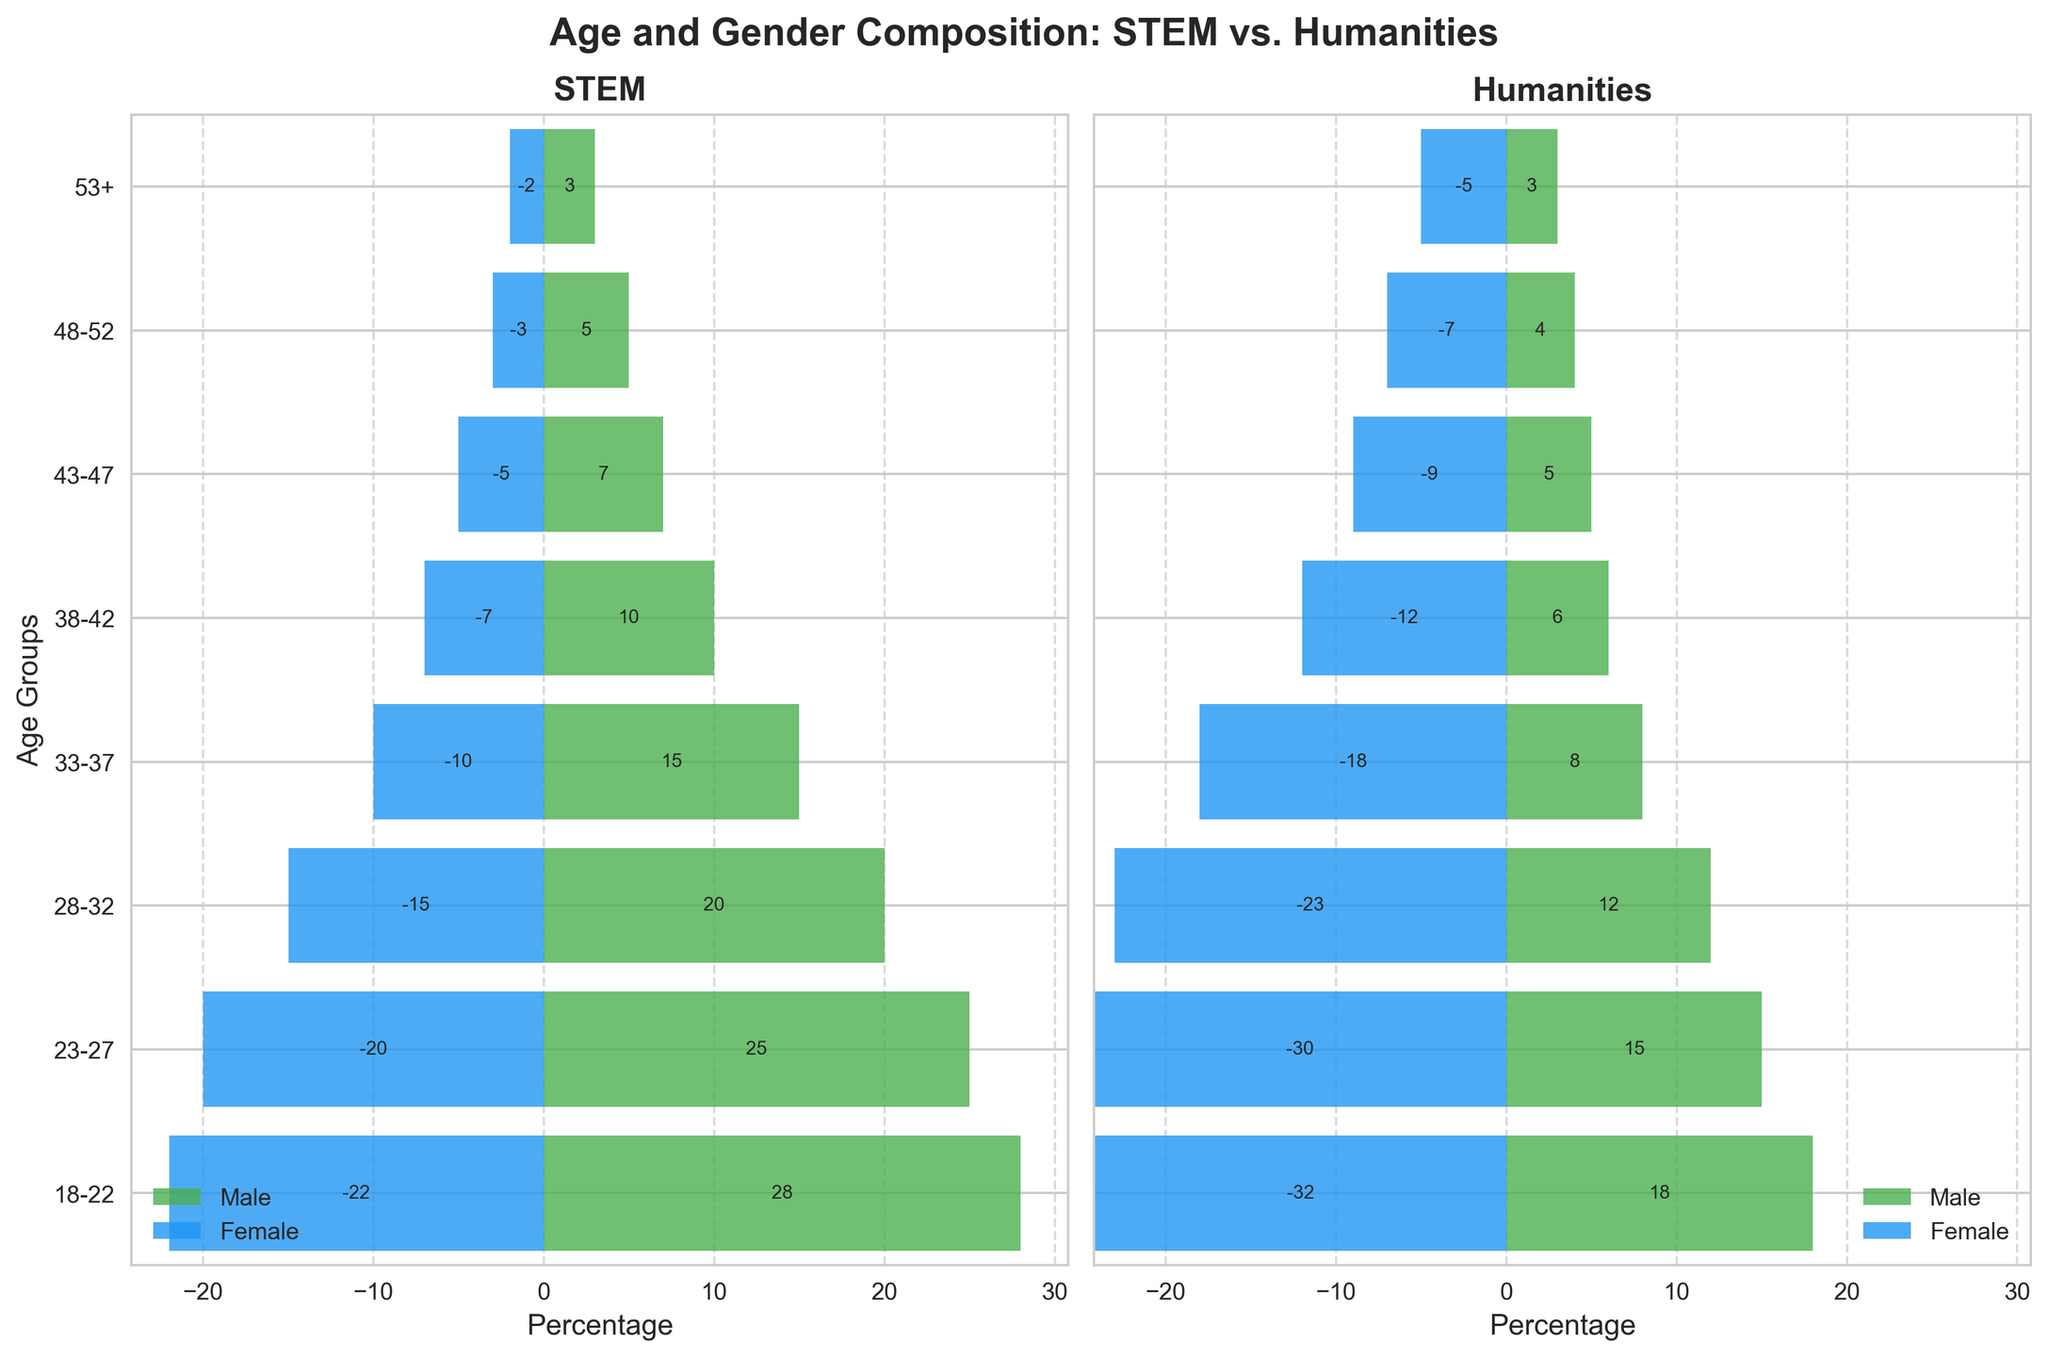Which age group has the highest number of STEM males? By examining the figure, find the age group bar that extends the farthest to the right in the STEM male section.
Answer: 18-22 Which age group has the lowest number of Humanities females? Identify the age group bar that extends the least to the left in the Humanities female section.
Answer: 53+ How does the number of Humanities females aged 23-27 compare to the number of STEM females in the same age group? Compare the length of the bars for Humanities females and STEM females aged 23-27 and find which bar extends further. The Humanities bar extends longer.
Answer: Humanities females are higher What's the total number of STEM males across all age groups? Sum the lengths of the bars for STEM males across all age groups: 28 + 25 + 20 + 15 + 10 + 7 + 5 + 3 = 113.
Answer: 113 Which gender has more students aged 33-37 in STEM fields? Compare the lengths of the bars for STEM males and STEM females aged 33-37, noting that the male bar extends further to the right.
Answer: Males Which is higher: the number of STEM males aged 28-32 or the number of Humanities males aged 28-32? Compare the lengths of the bars for STEM males and Humanities males aged 28-32, noting that the STEM bar is longer.
Answer: STEM males What is the difference between the number of STEM females and Humanities females aged 43-47? Subtract the length of the bar for STEM females aged 43-47 from the bar for Humanities females aged 43-47: 9 - 5 = 4.
Answer: 4 Which gender and age group combination has the least number of students in the Humanities field? Identify the age group bar that extends the least in both the male and female sections of the Humanities plot.
Answer: Humanities females (53+) How does the number of STEM males aged 18-22 compare to the number of Humanities females aged 18-22? Compare the lengths of the bars for STEM males and Humanities females aged 18-22, noting that the STEM male bar is a bit shorter.
Answer: Humanities females are slightly higher What is the ratio of STEM males to females in the 23-27 age group? Divide the number of STEM males by the number of STEM females in the 23-27 age group: 25 / 20 = 1.25.
Answer: 1.25 